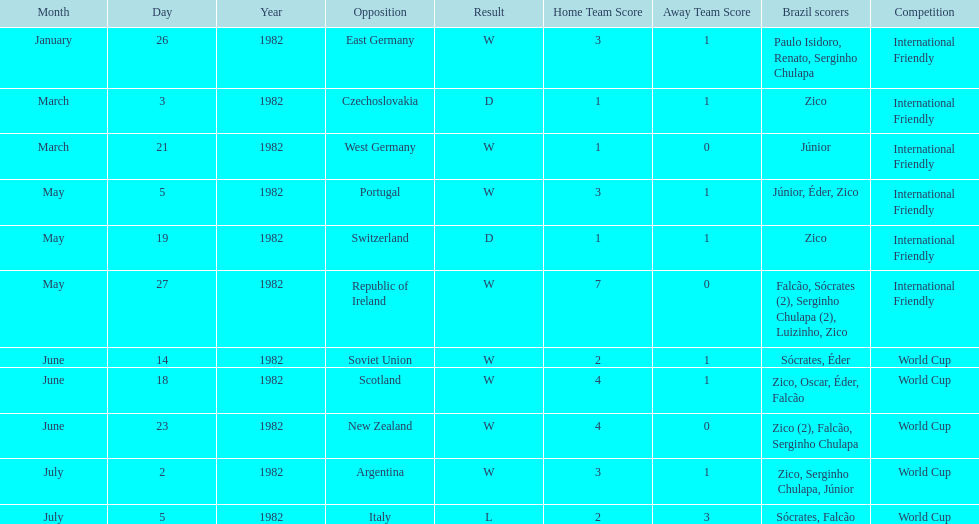Parse the full table. {'header': ['Month', 'Day', 'Year', 'Opposition', 'Result', 'Home Team Score', 'Away Team Score', 'Brazil scorers', 'Competition'], 'rows': [['January', '26', '1982', 'East Germany', 'W', '3', '1', 'Paulo Isidoro, Renato, Serginho Chulapa', 'International Friendly'], ['March', '3', '1982', 'Czechoslovakia', 'D', '1', '1', 'Zico', 'International Friendly'], ['March', '21', '1982', 'West Germany', 'W', '1', '0', 'Júnior', 'International Friendly'], ['May', '5', '1982', 'Portugal', 'W', '3', '1', 'Júnior, Éder, Zico', 'International Friendly'], ['May', '19', '1982', 'Switzerland', 'D', '1', '1', 'Zico', 'International Friendly'], ['May', '27', '1982', 'Republic of Ireland', 'W', '7', '0', 'Falcão, Sócrates (2), Serginho Chulapa (2), Luizinho, Zico', 'International Friendly'], ['June', '14', '1982', 'Soviet Union', 'W', '2', '1', 'Sócrates, Éder', 'World Cup'], ['June', '18', '1982', 'Scotland', 'W', '4', '1', 'Zico, Oscar, Éder, Falcão', 'World Cup'], ['June', '23', '1982', 'New Zealand', 'W', '4', '0', 'Zico (2), Falcão, Serginho Chulapa', 'World Cup'], ['July', '2', '1982', 'Argentina', 'W', '3', '1', 'Zico, Serginho Chulapa, Júnior', 'World Cup'], ['July', '5', '1982', 'Italy', 'L', '2', '3', 'Sócrates, Falcão', 'World Cup']]} Was the total goals scored on june 14, 1982 more than 6? No. 